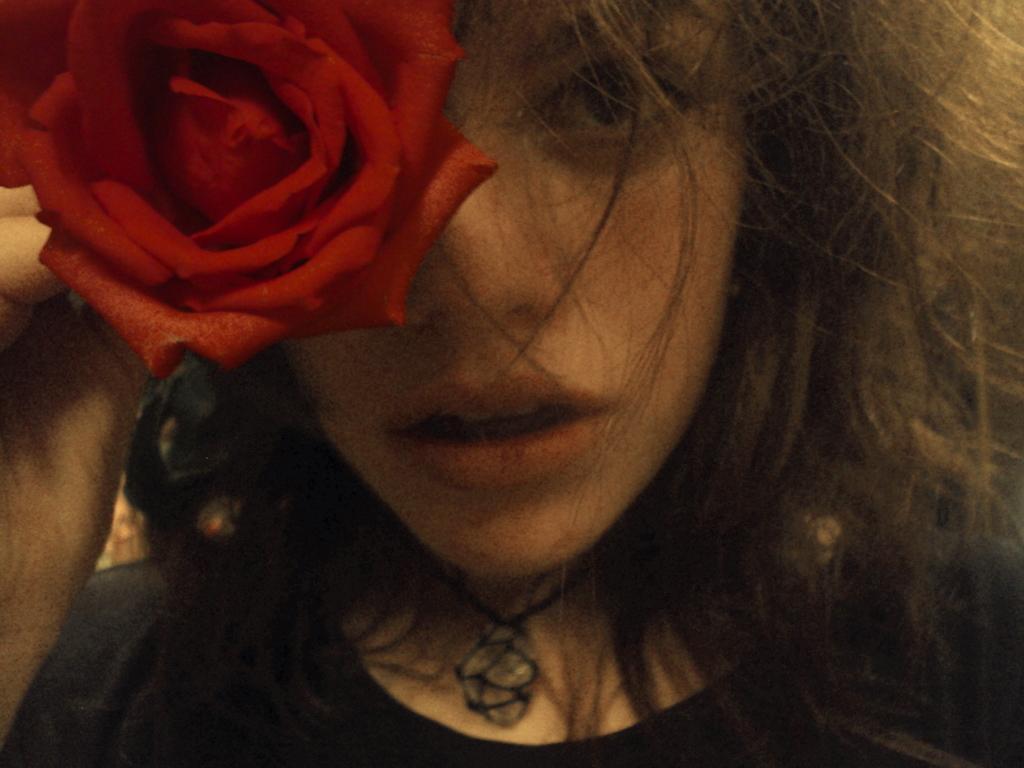Please provide a concise description of this image. In this image in the foreground there is one woman, who is holding a rose flower. 